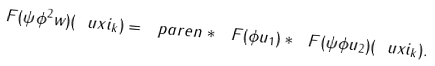<formula> <loc_0><loc_0><loc_500><loc_500>\ F ( \psi \phi ^ { 2 } w ) ( \ u x i _ { k } ) = \ p a r e n * { \ F ( \phi u _ { 1 } ) \ast \ F ( \psi \phi u _ { 2 } ) } ( \ u x i _ { k } ) .</formula> 